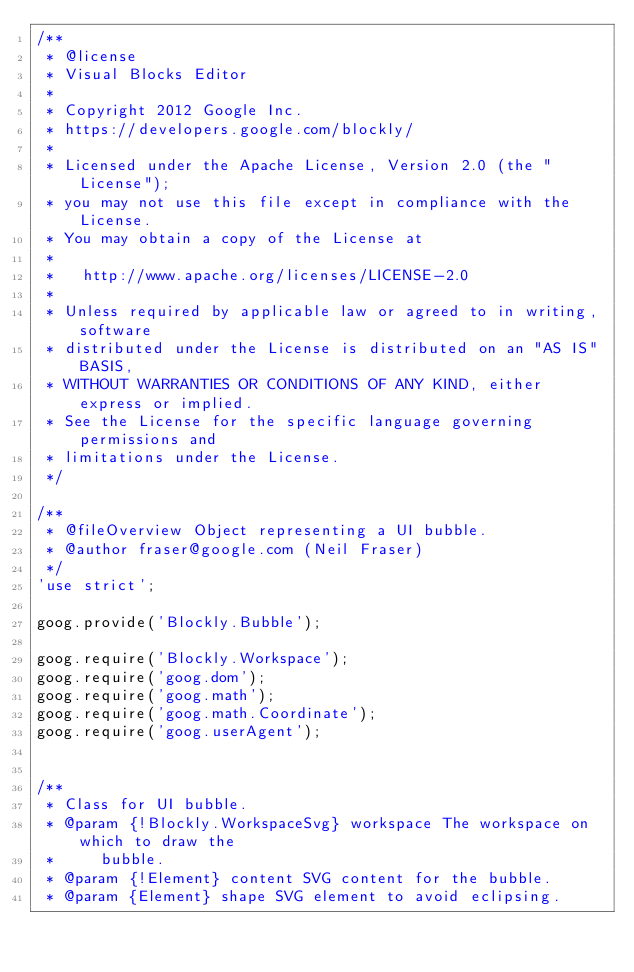Convert code to text. <code><loc_0><loc_0><loc_500><loc_500><_JavaScript_>/**
 * @license
 * Visual Blocks Editor
 *
 * Copyright 2012 Google Inc.
 * https://developers.google.com/blockly/
 *
 * Licensed under the Apache License, Version 2.0 (the "License");
 * you may not use this file except in compliance with the License.
 * You may obtain a copy of the License at
 *
 *   http://www.apache.org/licenses/LICENSE-2.0
 *
 * Unless required by applicable law or agreed to in writing, software
 * distributed under the License is distributed on an "AS IS" BASIS,
 * WITHOUT WARRANTIES OR CONDITIONS OF ANY KIND, either express or implied.
 * See the License for the specific language governing permissions and
 * limitations under the License.
 */

/**
 * @fileOverview Object representing a UI bubble.
 * @author fraser@google.com (Neil Fraser)
 */
'use strict';

goog.provide('Blockly.Bubble');

goog.require('Blockly.Workspace');
goog.require('goog.dom');
goog.require('goog.math');
goog.require('goog.math.Coordinate');
goog.require('goog.userAgent');


/**
 * Class for UI bubble.
 * @param {!Blockly.WorkspaceSvg} workspace The workspace on which to draw the
 *     bubble.
 * @param {!Element} content SVG content for the bubble.
 * @param {Element} shape SVG element to avoid eclipsing.</code> 